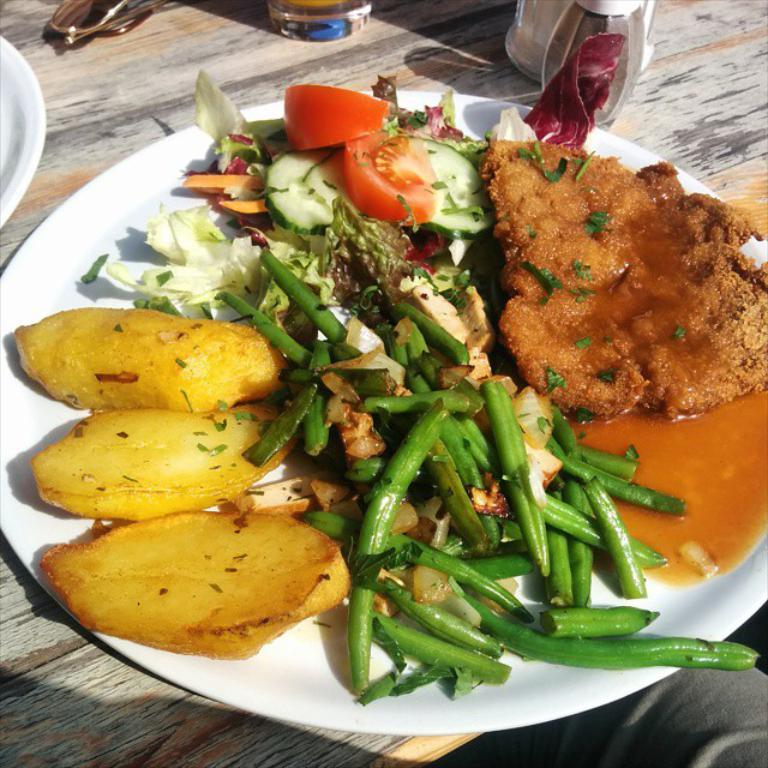What type of food can be seen in the image? There is food in the image, and it contains vegetables. How is the food arranged or presented? The food is on a plate in the image. Where is the plate with food located? The plate with food is on a table. What other objects are present on the table? There is a glass and another plate in the image. Is there a person visible in the image? Yes, there is a human visible in the image. What type of zipper can be seen on the authority figure in the image? There is no authority figure or zipper present in the image. What book is the person reading in the image? There is no reading or book visible in the image. 